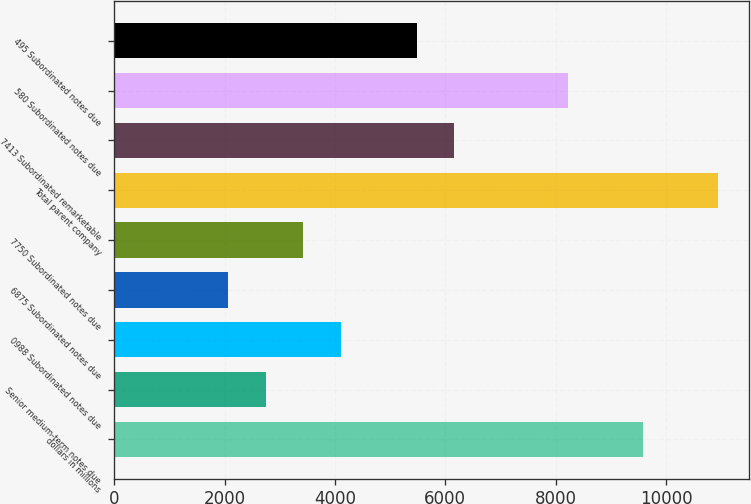Convert chart. <chart><loc_0><loc_0><loc_500><loc_500><bar_chart><fcel>dollars in millions<fcel>Senior medium-term notes due<fcel>0988 Subordinated notes due<fcel>6875 Subordinated notes due<fcel>7750 Subordinated notes due<fcel>Total parent company<fcel>7413 Subordinated remarketable<fcel>580 Subordinated notes due<fcel>495 Subordinated notes due<nl><fcel>9582.2<fcel>2744.2<fcel>4111.8<fcel>2060.4<fcel>3428<fcel>10949.8<fcel>6163.2<fcel>8214.6<fcel>5479.4<nl></chart> 